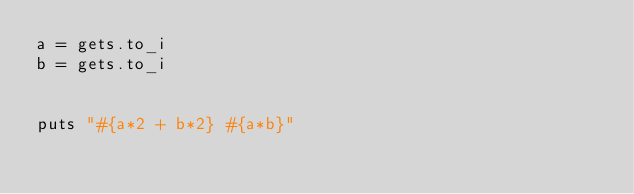Convert code to text. <code><loc_0><loc_0><loc_500><loc_500><_Ruby_>a = gets.to_i
b = gets.to_i


puts "#{a*2 + b*2} #{a*b}"
</code> 